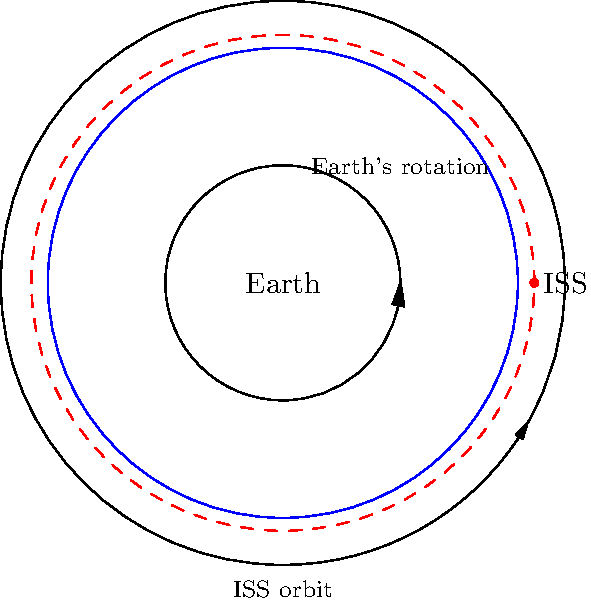As a Rotterdam native interested in space exploration, you might find it fascinating to know that the International Space Station (ISS) orbits Earth multiple times a day. Given that the ISS completes about 15.5 orbits around Earth in 24 hours, approximately how long does it take for the ISS to complete one orbit? To solve this problem, we'll follow these steps:

1. Understand the given information:
   - The ISS completes about 15.5 orbits in 24 hours.

2. Set up the equation:
   Let $x$ be the time for one orbit in hours.
   $\frac{24 \text{ hours}}{x \text{ hours per orbit}} = 15.5 \text{ orbits}$

3. Solve for $x$:
   $x = \frac{24 \text{ hours}}{15.5 \text{ orbits}}$

4. Calculate the result:
   $x \approx 1.548 \text{ hours}$

5. Convert hours to minutes:
   $1.548 \text{ hours} \times 60 \text{ minutes/hour} \approx 92.9 \text{ minutes}$

Therefore, it takes approximately 93 minutes for the ISS to complete one orbit around Earth.

This rapid orbit allows the ISS to conduct various scientific experiments and Earth observations, which could be of interest to PvdA supporters concerned with climate change and environmental issues.
Answer: 93 minutes 